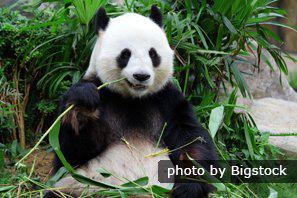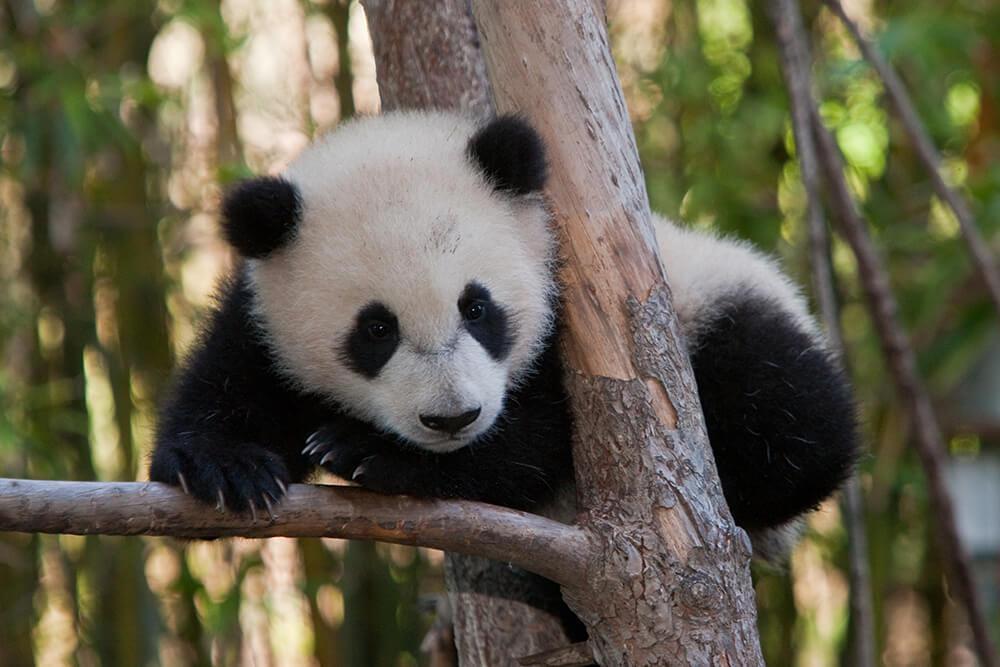The first image is the image on the left, the second image is the image on the right. Analyze the images presented: Is the assertion "The lefthand image contains one panda, which is holding a green stalk." valid? Answer yes or no. Yes. The first image is the image on the left, the second image is the image on the right. Examine the images to the left and right. Is the description "The panda in the left image has a bamboo stock in their hand." accurate? Answer yes or no. Yes. 